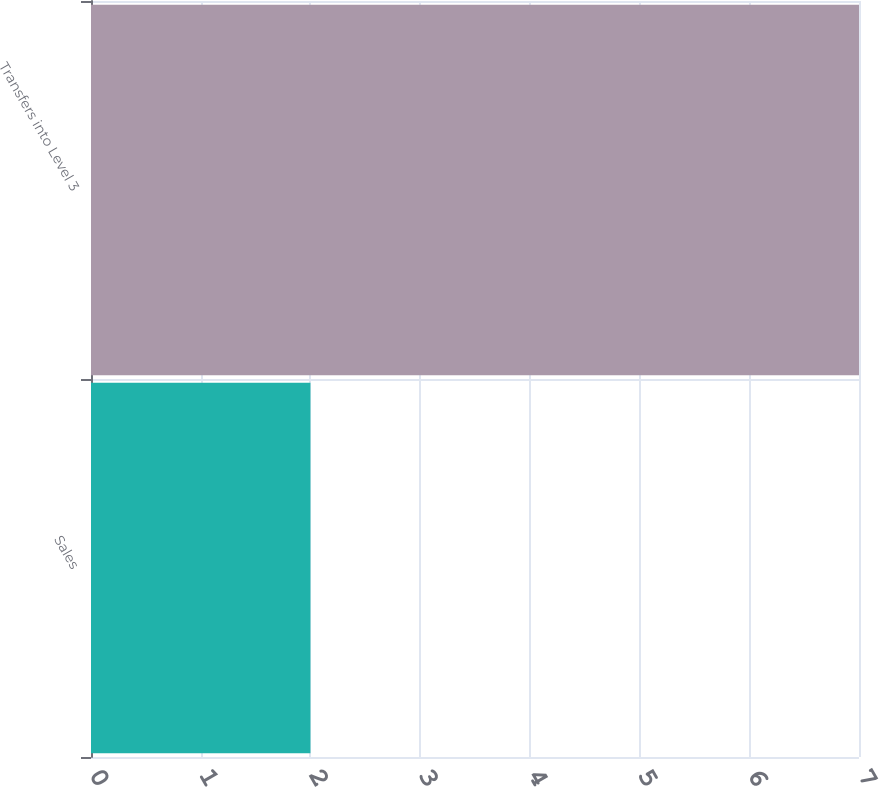<chart> <loc_0><loc_0><loc_500><loc_500><bar_chart><fcel>Sales<fcel>Transfers into Level 3<nl><fcel>2<fcel>7<nl></chart> 